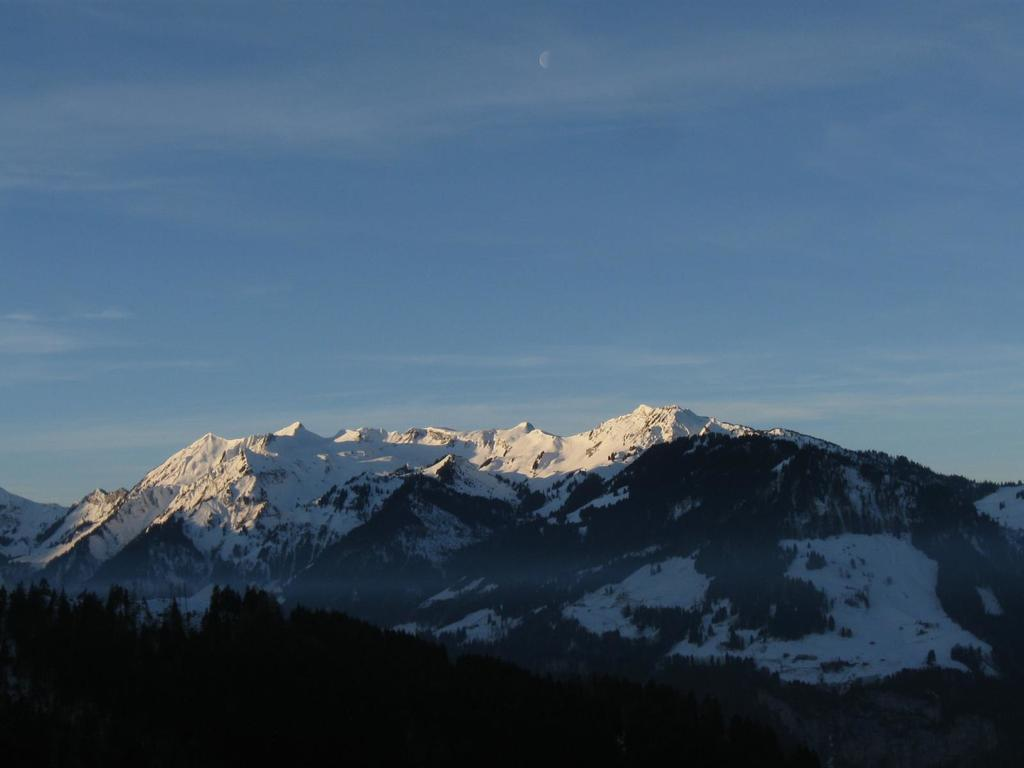What type of vegetation is in the foreground of the picture? There are trees in the foreground of the picture. What geographical feature is located in the center of the picture? There are mountains in the center of the picture. What is the condition of the mountains in the image? The mountains are covered with snow. What is visible at the top of the image? The sky is visible at the top of the image. What type of insurance is required to climb the snow-covered mountains in the image? There is no mention of climbing or any need for insurance in the image. The mountains are covered with snow, but the image does not provide any information about the need for insurance or any activity related to the mountains. 